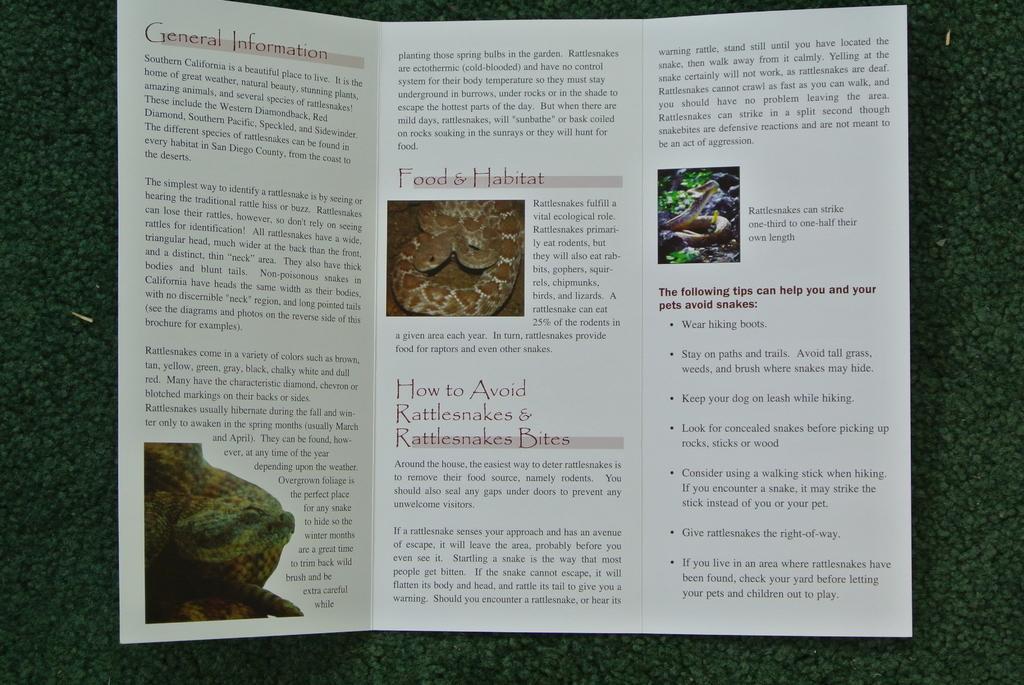In one or two sentences, can you explain what this image depicts? In this image, we can see a card is placed on the green surface. In this card, we can see some information and images. 